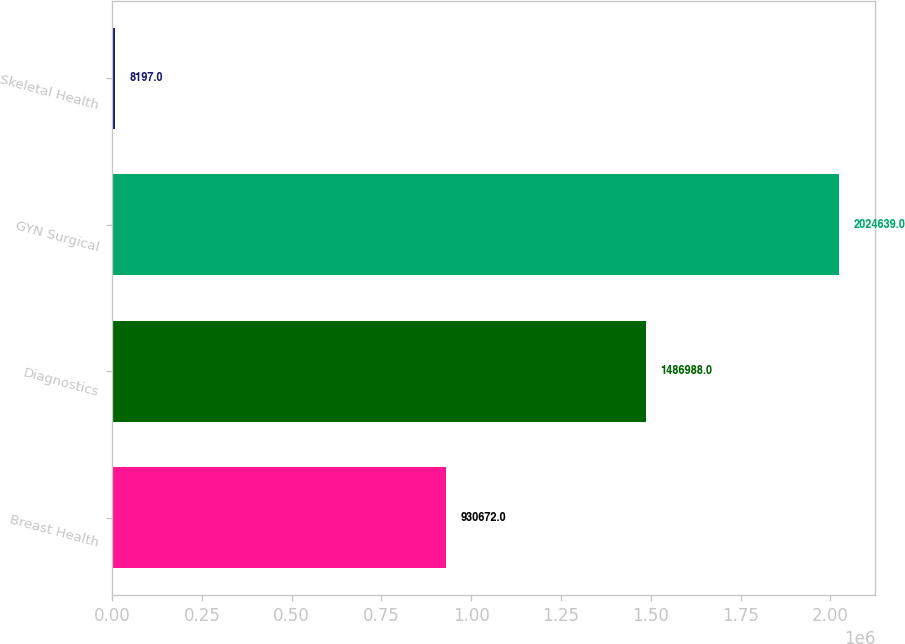Convert chart to OTSL. <chart><loc_0><loc_0><loc_500><loc_500><bar_chart><fcel>Breast Health<fcel>Diagnostics<fcel>GYN Surgical<fcel>Skeletal Health<nl><fcel>930672<fcel>1.48699e+06<fcel>2.02464e+06<fcel>8197<nl></chart> 